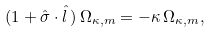<formula> <loc_0><loc_0><loc_500><loc_500>( 1 + \hat { \sigma } \cdot { \hat { l } } \, ) \, \Omega _ { \kappa , m } = - \kappa \, \Omega _ { \kappa , m } ,</formula> 